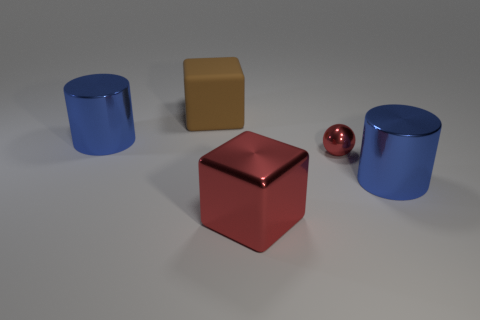There is a brown matte object that is the same shape as the big red metal thing; what is its size?
Provide a succinct answer. Large. Is the number of red metallic spheres that are to the left of the matte object less than the number of purple metallic spheres?
Make the answer very short. No. There is a object to the left of the big brown rubber thing; what shape is it?
Provide a succinct answer. Cylinder. There is a matte thing; is it the same size as the cube that is in front of the tiny red metallic sphere?
Offer a terse response. Yes. Are there any other tiny red balls that have the same material as the tiny red ball?
Give a very brief answer. No. How many blocks are either red metallic things or purple rubber things?
Your answer should be compact. 1. Is there a blue metal cylinder in front of the cube that is in front of the tiny object?
Offer a very short reply. No. Is the number of large cylinders less than the number of small blue rubber cylinders?
Ensure brevity in your answer.  No. What number of other large things have the same shape as the large brown thing?
Your answer should be compact. 1. What number of gray objects are big cylinders or matte things?
Provide a short and direct response. 0. 